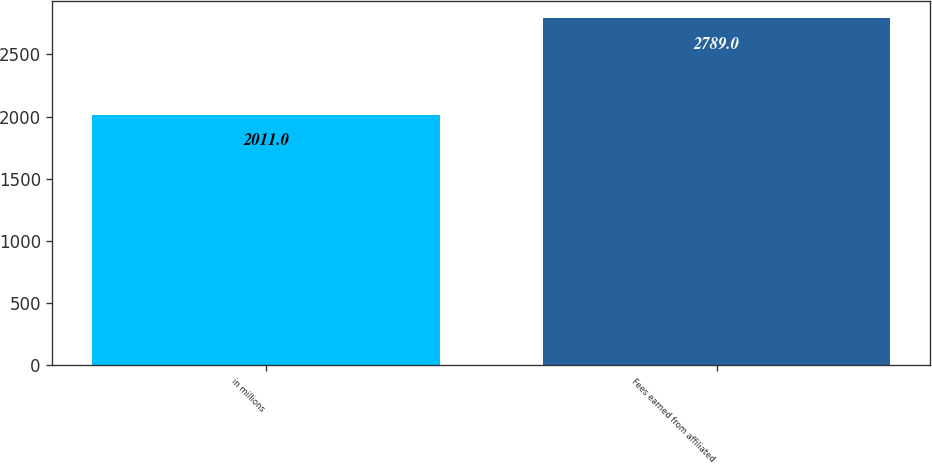<chart> <loc_0><loc_0><loc_500><loc_500><bar_chart><fcel>in millions<fcel>Fees earned from affiliated<nl><fcel>2011<fcel>2789<nl></chart> 